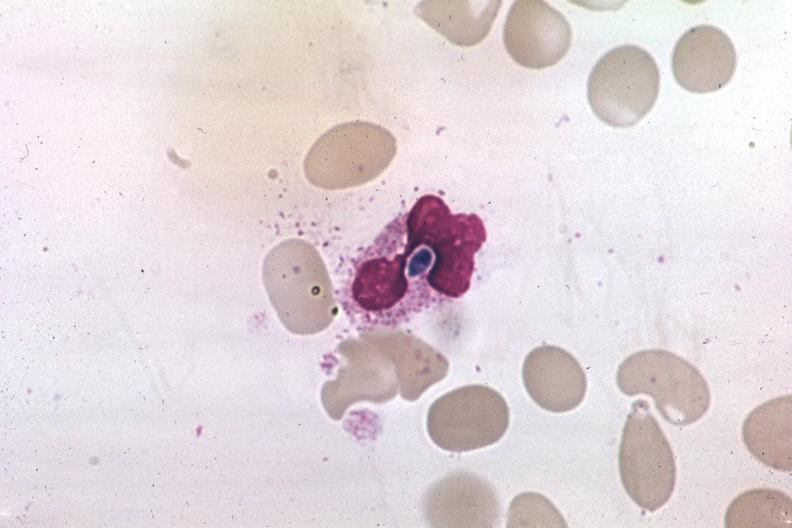s this typical lesion present?
Answer the question using a single word or phrase. No 